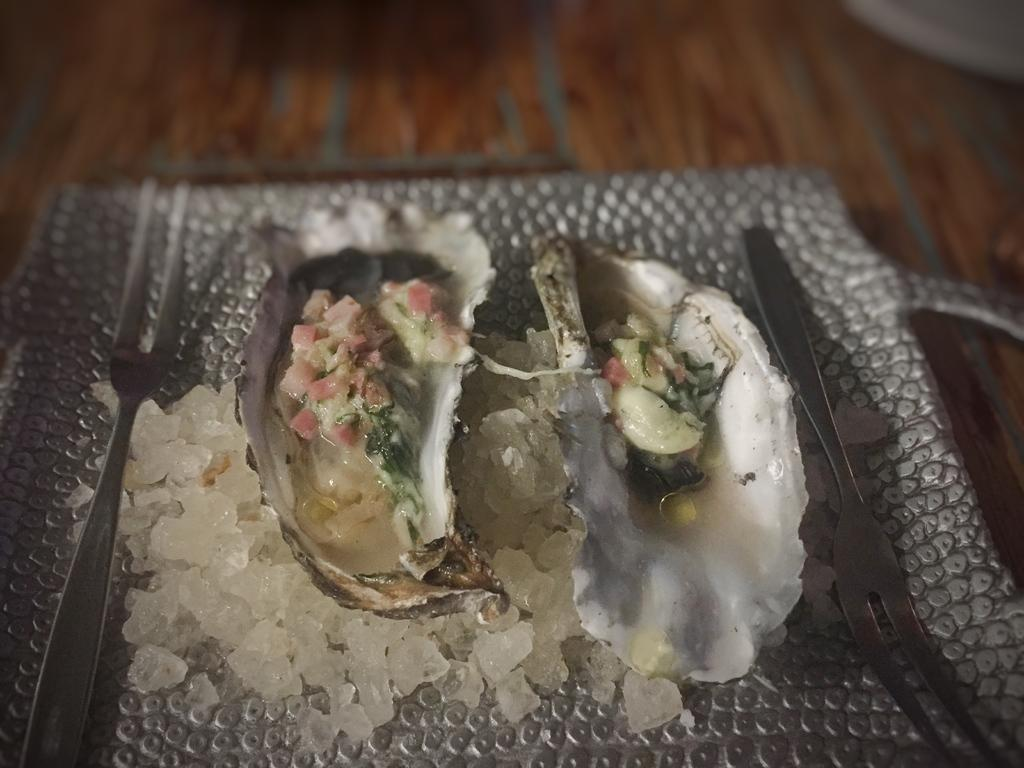What is the main subject of the image? There is a food item in the image. What utensils are present in the image? There are forks in the image. What color is the plate that holds the food item and forks? The plate is a grey color. What is the color and material of the surface on which the plate is placed? The surface is brown in color and appears to be made of a solid material. How many carts are visible in the image? There are no carts present in the image. What type of feather can be seen on the food item in the image? There are no feathers present on the food item in the image. 